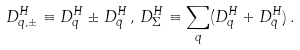Convert formula to latex. <formula><loc_0><loc_0><loc_500><loc_500>D _ { q , \pm } ^ { H } \equiv D _ { q } ^ { H } \pm D _ { \bar { q } } ^ { H } \, , \, D _ { \Sigma } ^ { H } \equiv \sum _ { q } ( D _ { q } ^ { H } + D _ { \bar { q } } ^ { H } ) \, .</formula> 